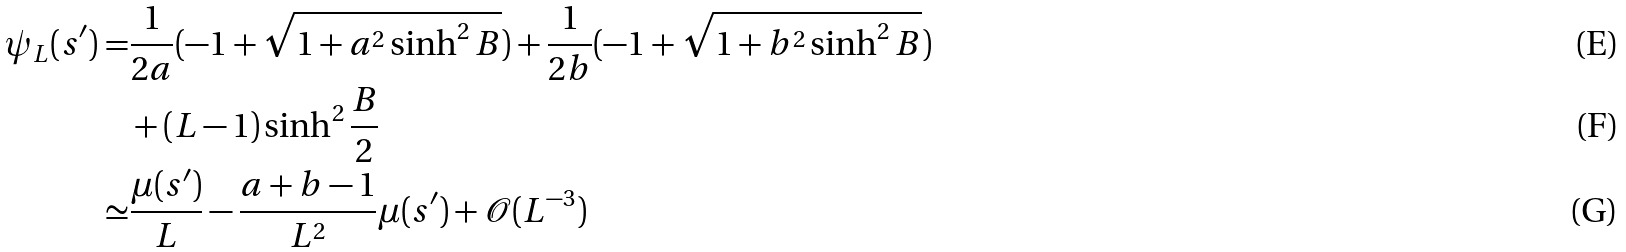Convert formula to latex. <formula><loc_0><loc_0><loc_500><loc_500>\psi _ { L } ( s ^ { \prime } ) = & \frac { 1 } { 2 a } ( - 1 + \sqrt { 1 + a ^ { 2 } \sinh ^ { 2 } B } ) + \frac { 1 } { 2 b } ( - 1 + \sqrt { 1 + b ^ { 2 } \sinh ^ { 2 } B } ) \\ & + ( L - 1 ) \sinh ^ { 2 } \frac { B } { 2 } \\ \simeq & \frac { \mu ( s ^ { \prime } ) } { L } - \frac { a + b - 1 } { L ^ { 2 } } \mu ( s ^ { \prime } ) + { \mathcal { O } } ( L ^ { - 3 } )</formula> 